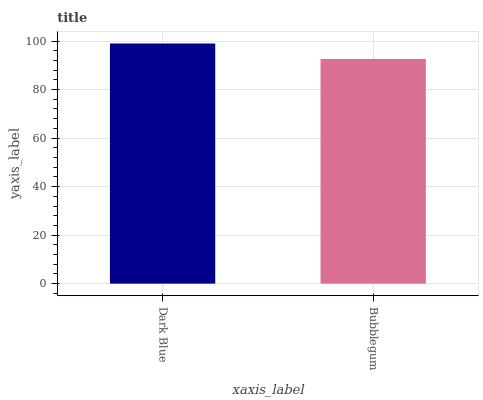Is Dark Blue the maximum?
Answer yes or no. Yes. Is Bubblegum the maximum?
Answer yes or no. No. Is Dark Blue greater than Bubblegum?
Answer yes or no. Yes. Is Bubblegum less than Dark Blue?
Answer yes or no. Yes. Is Bubblegum greater than Dark Blue?
Answer yes or no. No. Is Dark Blue less than Bubblegum?
Answer yes or no. No. Is Dark Blue the high median?
Answer yes or no. Yes. Is Bubblegum the low median?
Answer yes or no. Yes. Is Bubblegum the high median?
Answer yes or no. No. Is Dark Blue the low median?
Answer yes or no. No. 